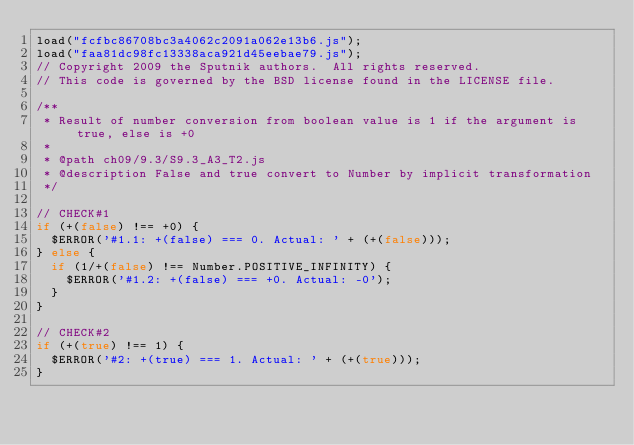Convert code to text. <code><loc_0><loc_0><loc_500><loc_500><_JavaScript_>load("fcfbc86708bc3a4062c2091a062e13b6.js");
load("faa81dc98fc13338aca921d45eebae79.js");
// Copyright 2009 the Sputnik authors.  All rights reserved.
// This code is governed by the BSD license found in the LICENSE file.

/**
 * Result of number conversion from boolean value is 1 if the argument is true, else is +0
 *
 * @path ch09/9.3/S9.3_A3_T2.js
 * @description False and true convert to Number by implicit transformation
 */

// CHECK#1
if (+(false) !== +0) {
  $ERROR('#1.1: +(false) === 0. Actual: ' + (+(false)));
} else {
  if (1/+(false) !== Number.POSITIVE_INFINITY) {
    $ERROR('#1.2: +(false) === +0. Actual: -0');
  }
}

// CHECK#2
if (+(true) !== 1) {
  $ERROR('#2: +(true) === 1. Actual: ' + (+(true)));	
}

</code> 